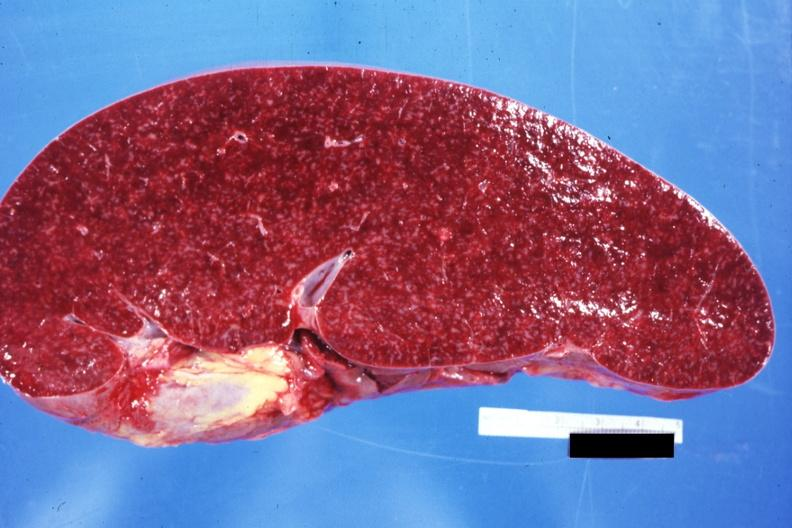where is this part in?
Answer the question using a single word or phrase. Spleen 